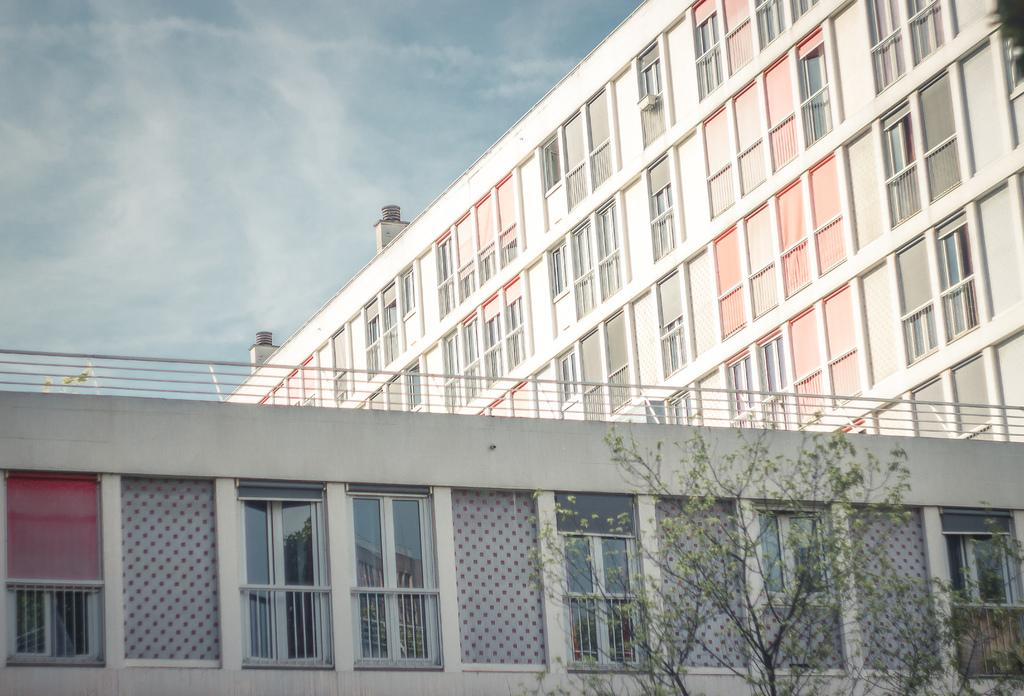What types of structures are present at the bottom and in the background of the image? There are buildings at the bottom and in the background of the image. What can be seen in the foreground of the image? There are trees in the foreground of the image. What is visible at the top of the image? The sky is visible at the top of the image. Can you see a needle in the sky in the image? There is no needle present in the sky in the image. What type of mist can be seen surrounding the trees in the foreground? There is no mist present in the image; only trees, buildings, and the sky are visible. 